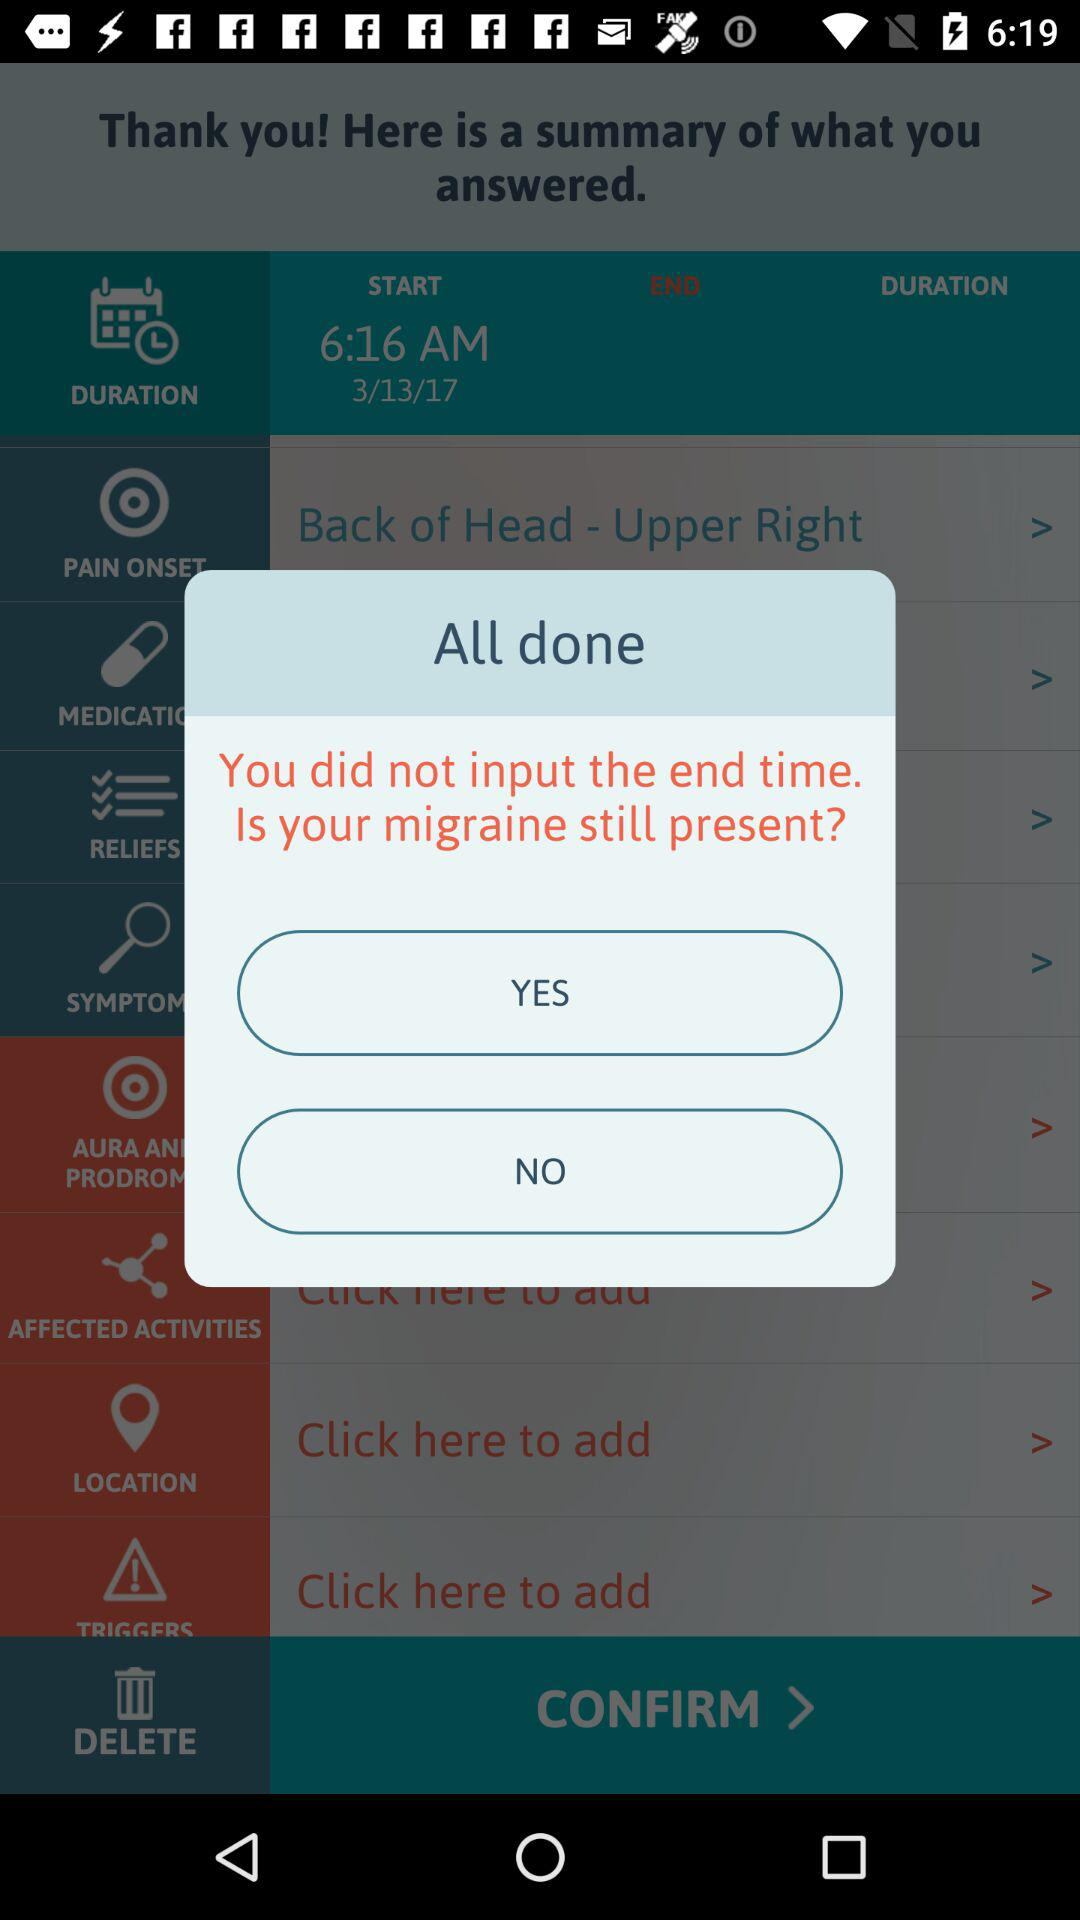Which tab is selected? The selected tab is "DURATION". 